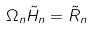<formula> <loc_0><loc_0><loc_500><loc_500>\Omega _ { n } \tilde { H } _ { n } = \tilde { R } _ { n }</formula> 